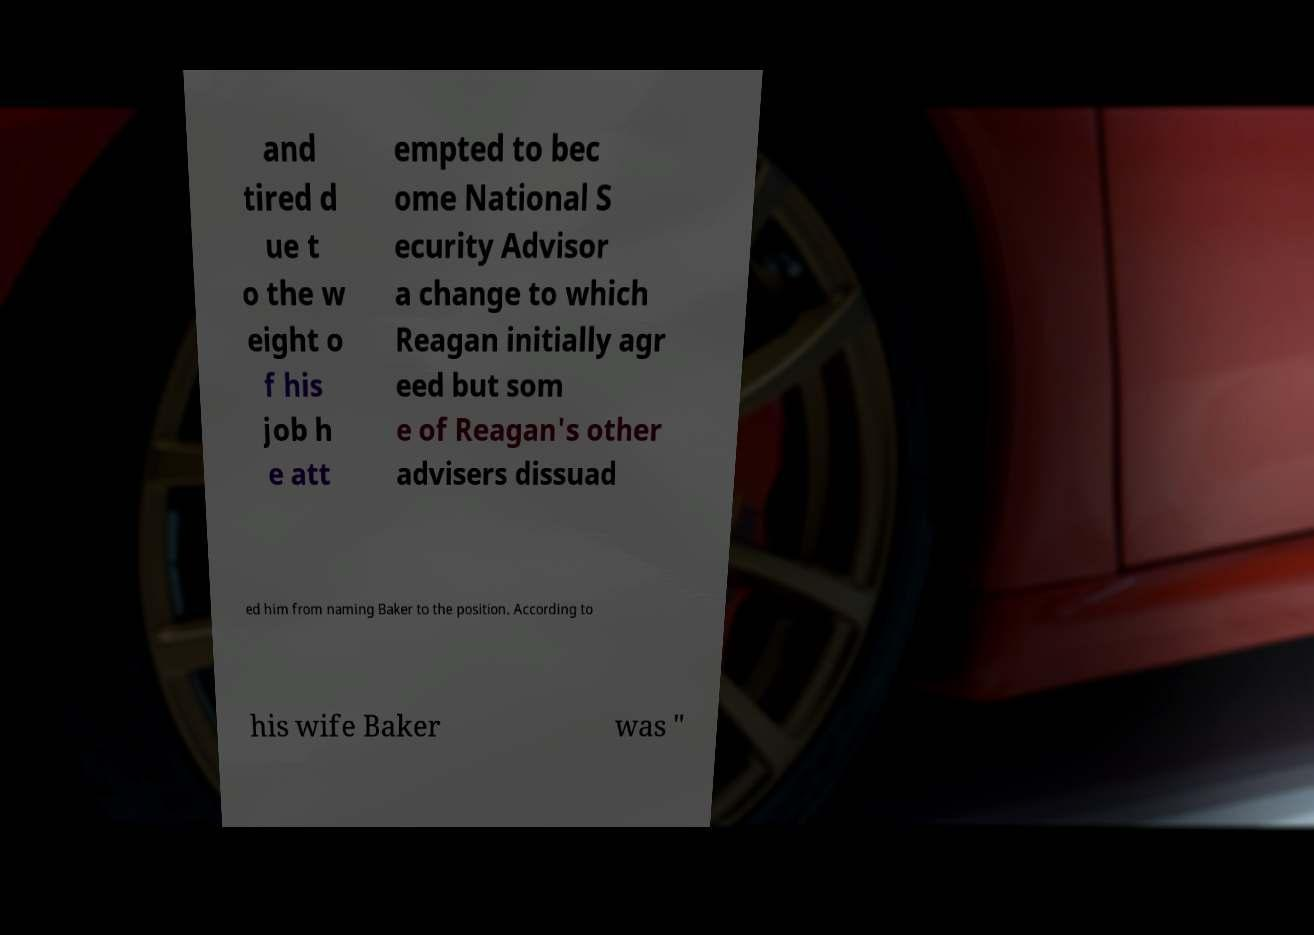Can you accurately transcribe the text from the provided image for me? and tired d ue t o the w eight o f his job h e att empted to bec ome National S ecurity Advisor a change to which Reagan initially agr eed but som e of Reagan's other advisers dissuad ed him from naming Baker to the position. According to his wife Baker was " 